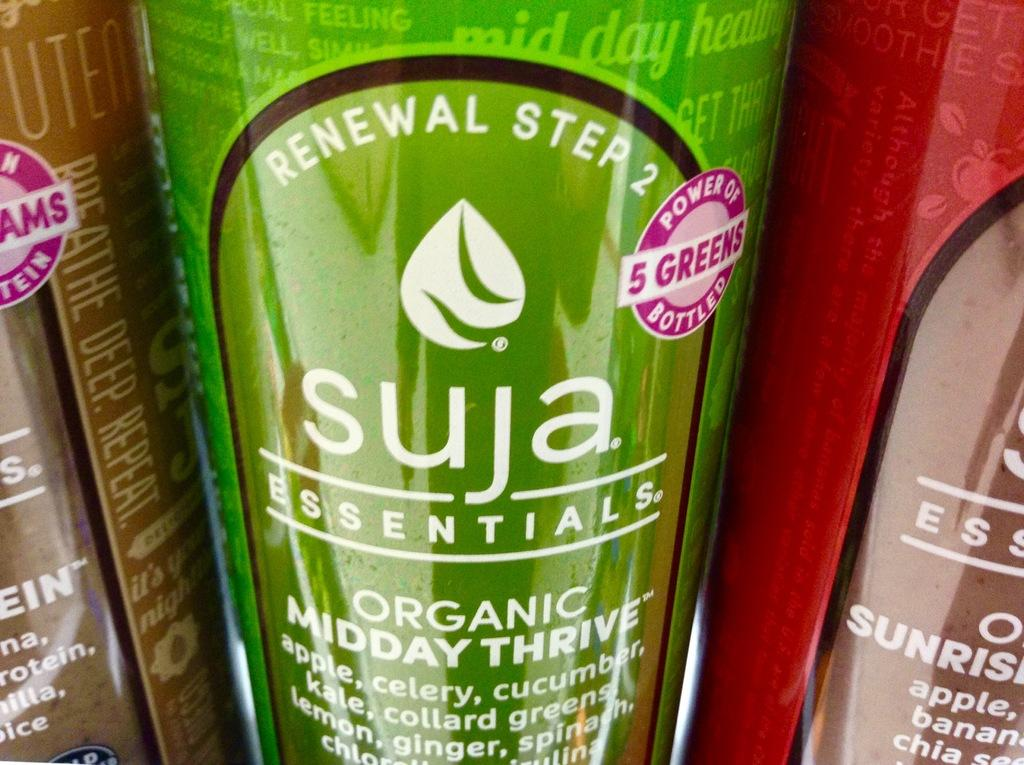<image>
Render a clear and concise summary of the photo. A group of beverages in a photo are made by Suja. 